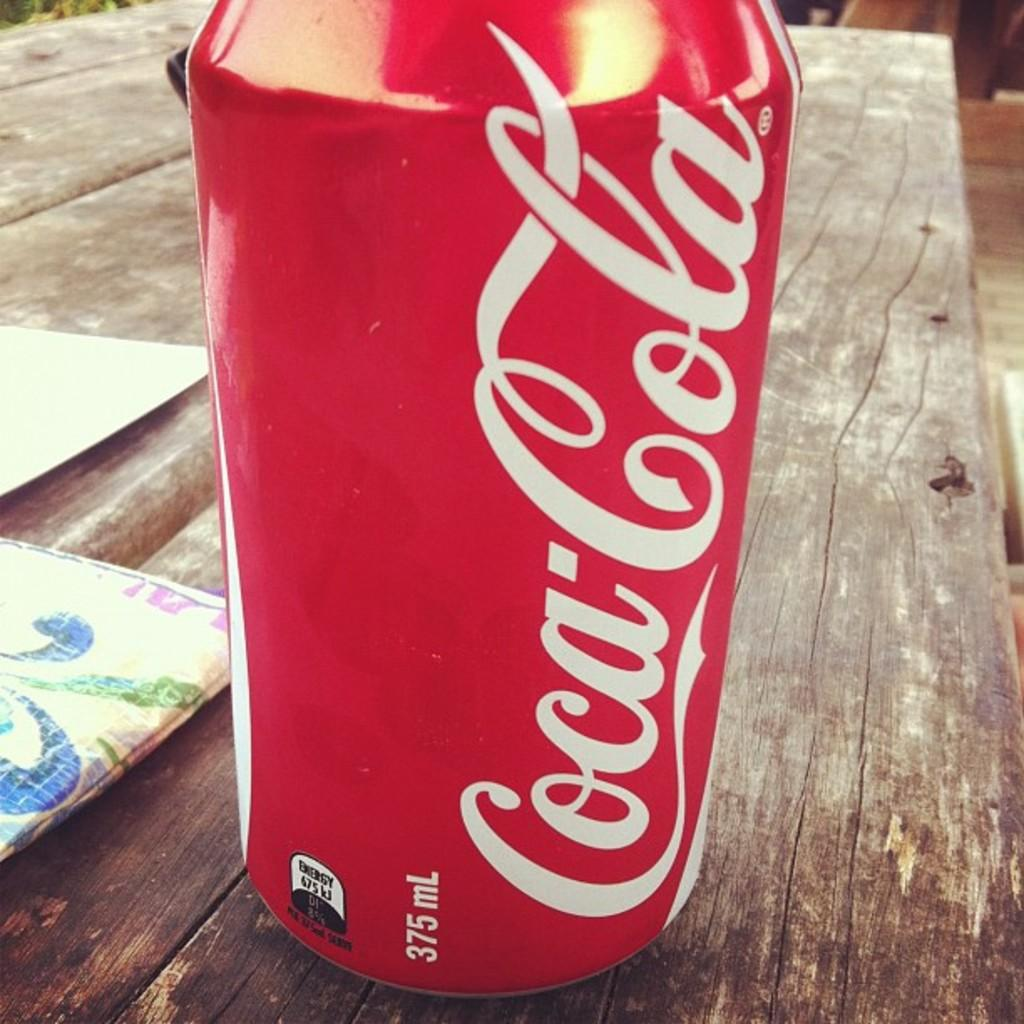<image>
Relay a brief, clear account of the picture shown. a very close close up of a 375 mL Coca Cola can 